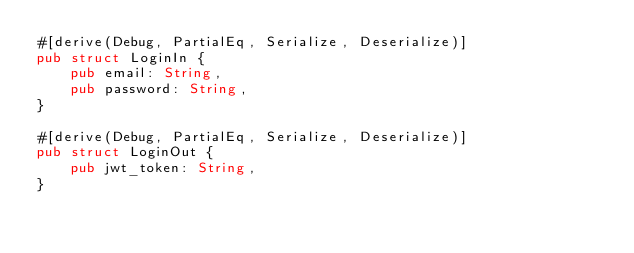Convert code to text. <code><loc_0><loc_0><loc_500><loc_500><_Rust_>#[derive(Debug, PartialEq, Serialize, Deserialize)]
pub struct LoginIn {
    pub email: String,
    pub password: String,
}

#[derive(Debug, PartialEq, Serialize, Deserialize)]
pub struct LoginOut {
    pub jwt_token: String,
}
</code> 